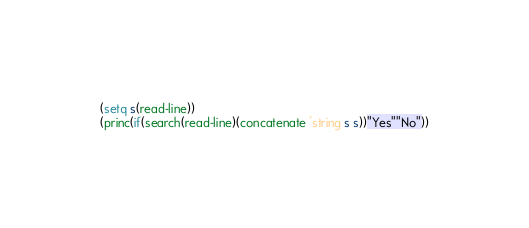Convert code to text. <code><loc_0><loc_0><loc_500><loc_500><_Lisp_>(setq s(read-line))
(princ(if(search(read-line)(concatenate 'string s s))"Yes""No"))</code> 